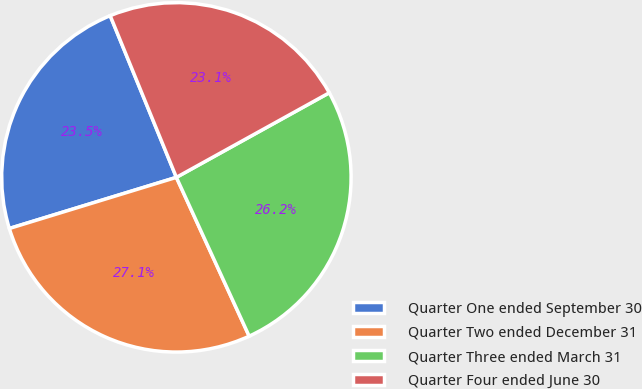Convert chart. <chart><loc_0><loc_0><loc_500><loc_500><pie_chart><fcel>Quarter One ended September 30<fcel>Quarter Two ended December 31<fcel>Quarter Three ended March 31<fcel>Quarter Four ended June 30<nl><fcel>23.54%<fcel>27.11%<fcel>26.2%<fcel>23.14%<nl></chart> 